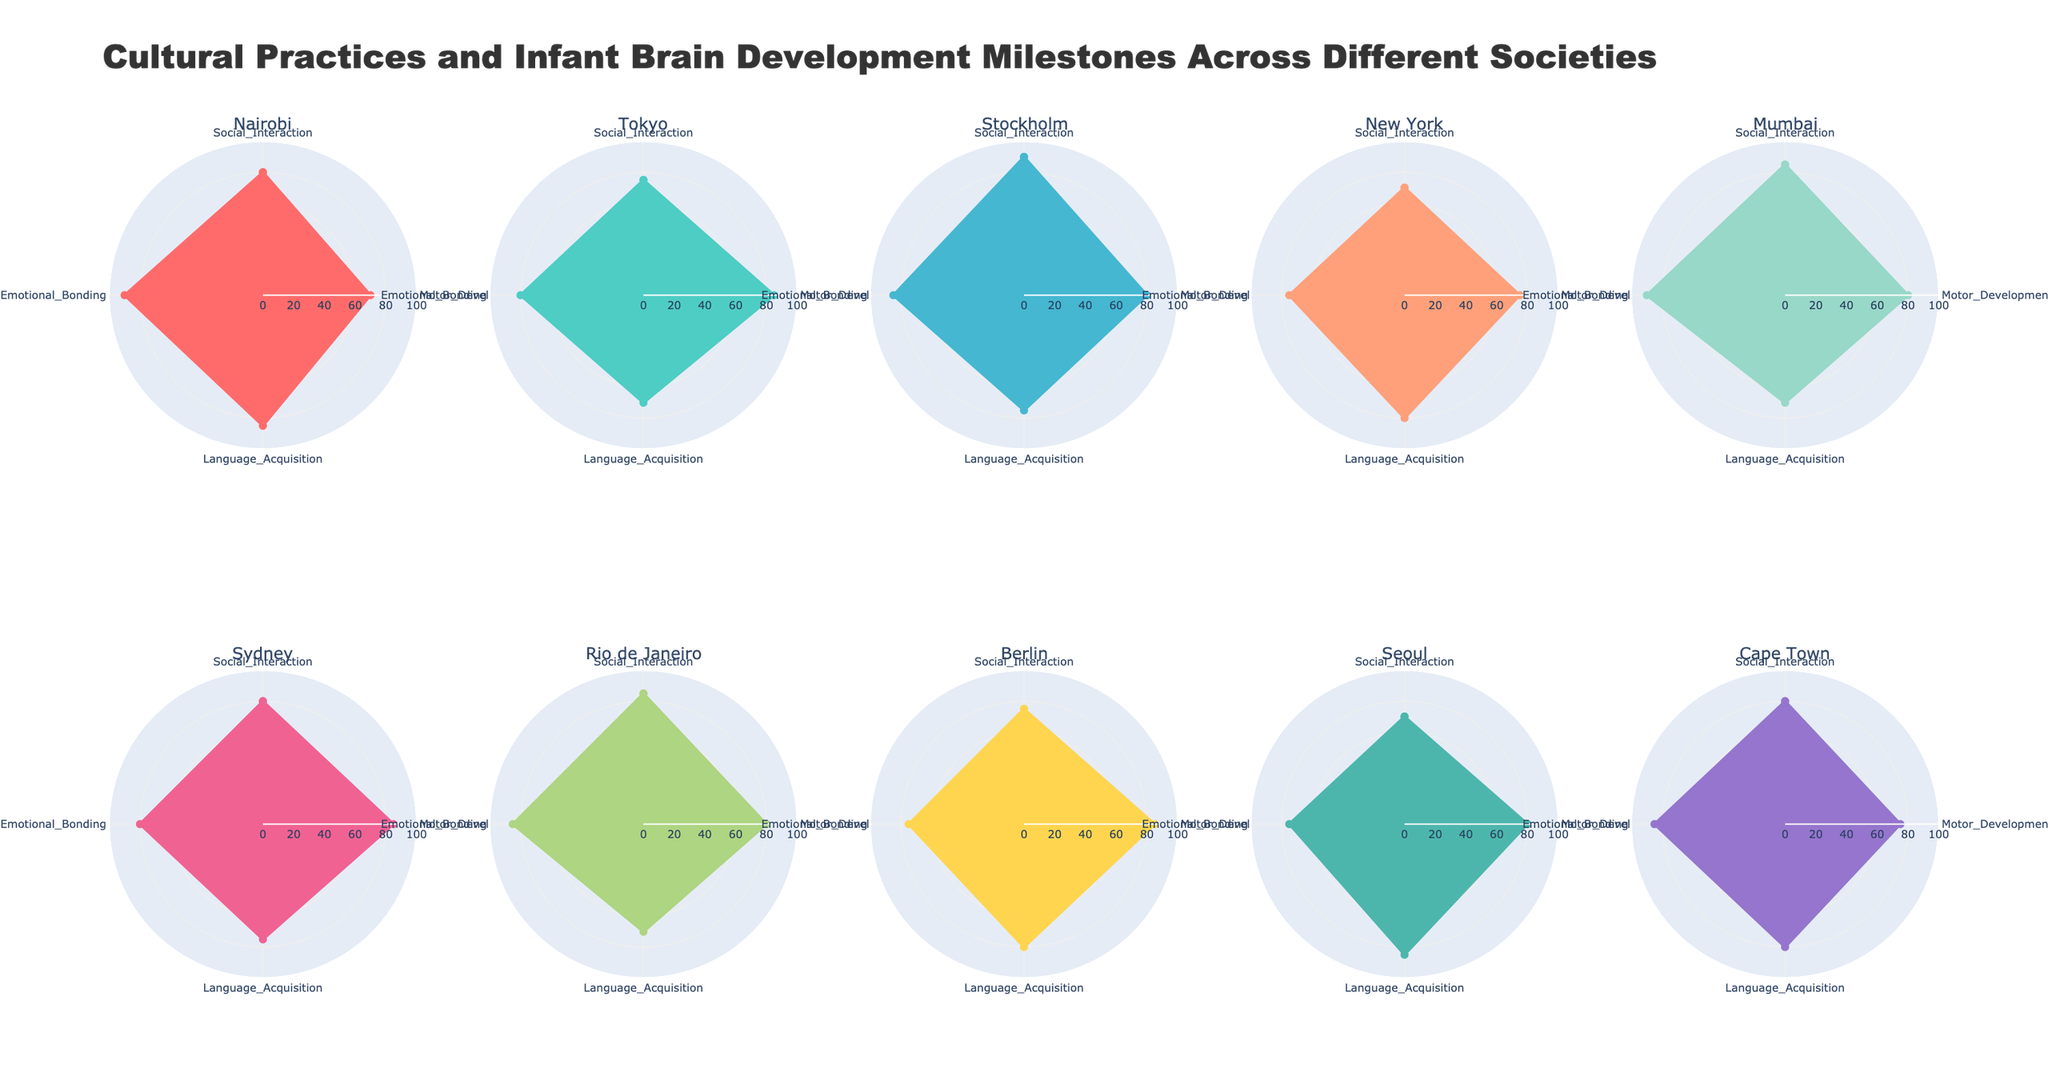Which region has the highest value for Social Interaction? To find the region with the highest Social Interaction value, compare each subplot's value for this axis. Nairobi and Stockholm both have a value of 90, which is tied for the highest.
Answer: Nairobi and Stockholm What is the average value of Language Acquisition across all regions? First, collect the Language Acquisition values from each subplot: Nairobi (85), Tokyo (70), Stockholm (75), New York (80), Mumbai (70), Sydney (75), Rio de Janeiro (70), Berlin (80), Seoul (85), Cape Town (80). Add the values: 85 + 70 + 75 + 80 + 70 + 75 + 70 + 80 + 85 + 80 = 770. There are 10 regions, so the average is 770 / 10 = 77
Answer: 77 Which region displays the most balanced development across all categories, with the least variation in values? To find the most balanced region, examine each subplot to identify the region where the values for Social Interaction, Motor Development, Language Acquisition, and Emotional Bonding are the most similar. Stockholm shows relatively balanced values: 90, 80, 75, 85 respectively.
Answer: Stockholm How does the Emotional Bonding score in Mumbai compare to New York? Look at the Emotional Bonding scores for Mumbai and New York. Mumbai has a score of 90 while New York has 75. Therefore, Mumbai's score is greater.
Answer: Mumbai has a higher score Which cultural practice is associated with the highest Motor Development score? Identify the Motor Development scores across all regions: Nairobi (70), Tokyo (85), Stockholm (80), New York (75), Mumbai (80), Sydney (85), Rio de Janeiro (80), Berlin (85), Seoul (80), Cape Town (75). The highest score is 85, associated with Tokyo (Group Daycare), Sydney (Outdoor Activities), and Berlin (Montessori Method).
Answer: Group Daycare, Outdoor Activities, Montessori Method What is the total sum of the Emotional Bonding scores across all regions? Add up the Emotional Bonding scores from each region: Nairobi (90), Tokyo (80), Stockholm (85), New York (75), Mumbai (90), Sydney (80), Rio de Janeiro (85), Berlin (75), Seoul (75), Cape Town (85). The total sum is 90 + 80 + 85 + 75 + 90 + 80 + 85 + 75 + 75 + 85 = 820
Answer: 820 Which region has the lowest Social Interaction score, and what practice do they use? Identify the Social Interaction scores for each region and find the minimum. Seoul has the lowest score of 70. Refer to the corresponding cultural practice, which is Tutoring Centers.
Answer: Seoul, Tutoring Centers How does Cape Town’s Motor Development compare to Tokyo's? Look at the Motor Development scores for Cape Town and Tokyo. Cape Town has a score of 75, while Tokyo has 85. Cape Town's score is lower.
Answer: Cape Town is lower What is the range of Social Interaction scores across all regions? The range is calculated by subtracting the lowest value from the highest value for Social Interaction. The highest is 90 (Stockholm), and the lowest is 70 (Seoul). Therefore, the range is 90 - 70 = 20
Answer: 20 Which region shows the highest value for Emotional Bonding, and what does this suggest about their cultural practice? Identify the Emotional Bonding scores for each region. Nairobi and Mumbai both score 90, the highest. Nairobi uses Kangaroo Mother Care, and Mumbai uses Extended Family Care. This suggests high emphasis on close contact and familial support.
Answer: Nairobi and Mumbai, close contact and familial support 